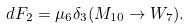<formula> <loc_0><loc_0><loc_500><loc_500>d F _ { 2 } = \mu _ { 6 } \delta _ { 3 } ( M _ { 1 0 } \rightarrow W _ { 7 } ) .</formula> 